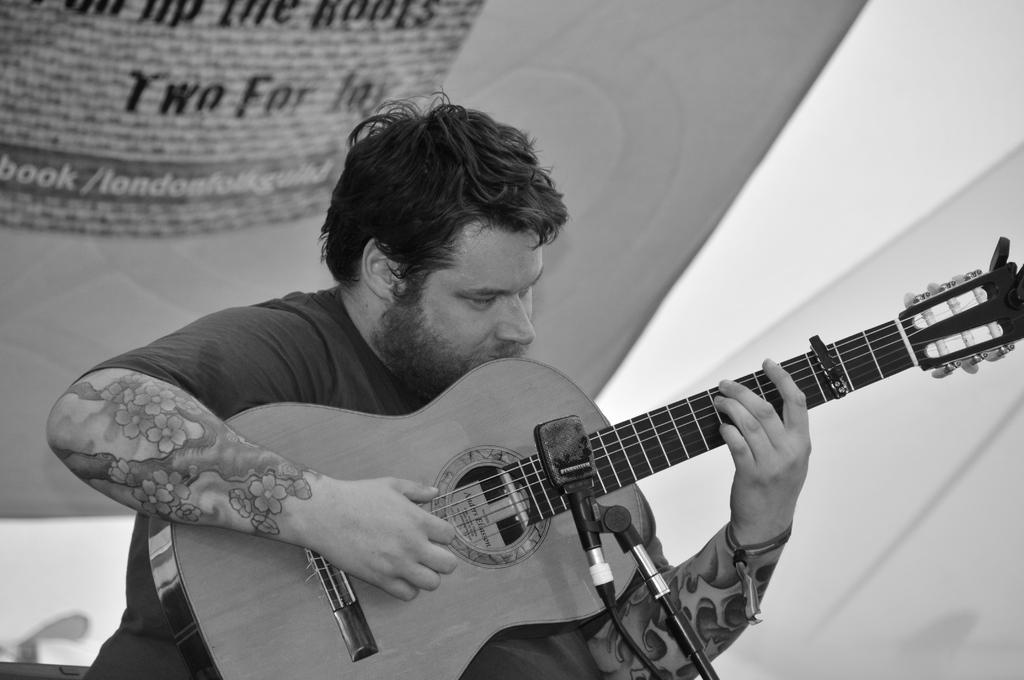Can you describe this image briefly? This picture shows a man seated and playing guitar and we see a microphone in front of him. 